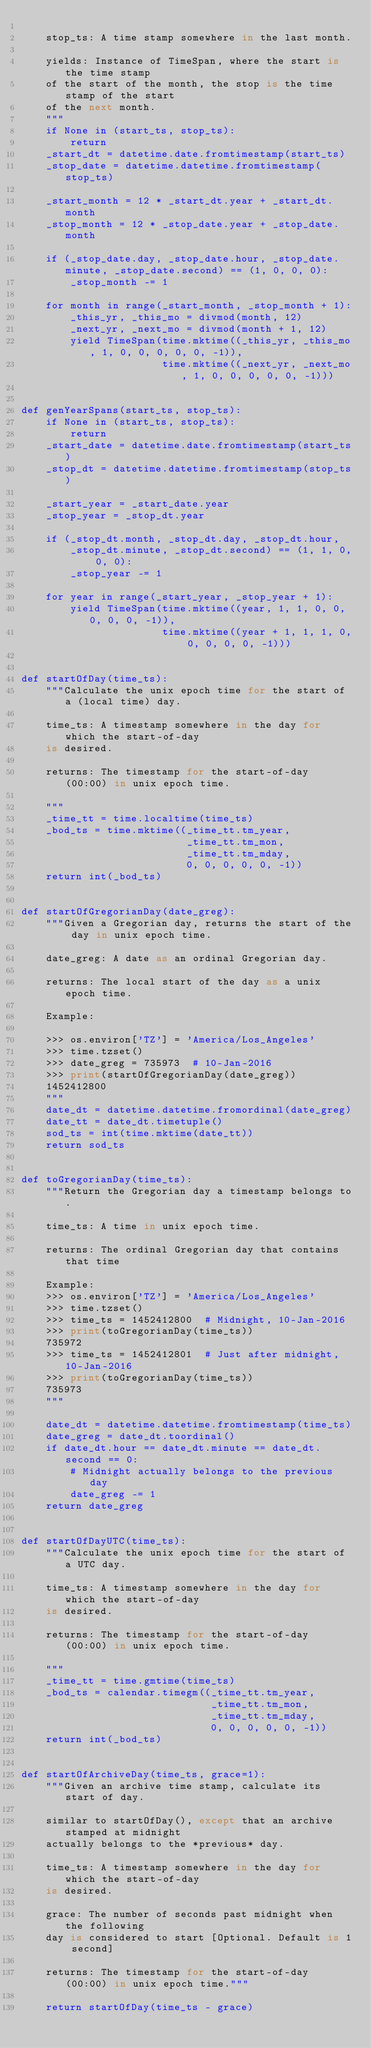Convert code to text. <code><loc_0><loc_0><loc_500><loc_500><_Python_>    
    stop_ts: A time stamp somewhere in the last month.
    
    yields: Instance of TimeSpan, where the start is the time stamp
    of the start of the month, the stop is the time stamp of the start
    of the next month.
    """
    if None in (start_ts, stop_ts):
        return
    _start_dt = datetime.date.fromtimestamp(start_ts)
    _stop_date = datetime.datetime.fromtimestamp(stop_ts)

    _start_month = 12 * _start_dt.year + _start_dt.month
    _stop_month = 12 * _stop_date.year + _stop_date.month

    if (_stop_date.day, _stop_date.hour, _stop_date.minute, _stop_date.second) == (1, 0, 0, 0):
        _stop_month -= 1

    for month in range(_start_month, _stop_month + 1):
        _this_yr, _this_mo = divmod(month, 12)
        _next_yr, _next_mo = divmod(month + 1, 12)
        yield TimeSpan(time.mktime((_this_yr, _this_mo, 1, 0, 0, 0, 0, 0, -1)),
                       time.mktime((_next_yr, _next_mo, 1, 0, 0, 0, 0, 0, -1)))


def genYearSpans(start_ts, stop_ts):
    if None in (start_ts, stop_ts):
        return
    _start_date = datetime.date.fromtimestamp(start_ts)
    _stop_dt = datetime.datetime.fromtimestamp(stop_ts)

    _start_year = _start_date.year
    _stop_year = _stop_dt.year

    if (_stop_dt.month, _stop_dt.day, _stop_dt.hour,
        _stop_dt.minute, _stop_dt.second) == (1, 1, 0, 0, 0):
        _stop_year -= 1

    for year in range(_start_year, _stop_year + 1):
        yield TimeSpan(time.mktime((year, 1, 1, 0, 0, 0, 0, 0, -1)),
                       time.mktime((year + 1, 1, 1, 0, 0, 0, 0, 0, -1)))


def startOfDay(time_ts):
    """Calculate the unix epoch time for the start of a (local time) day.
    
    time_ts: A timestamp somewhere in the day for which the start-of-day
    is desired.
    
    returns: The timestamp for the start-of-day (00:00) in unix epoch time.
    
    """
    _time_tt = time.localtime(time_ts)
    _bod_ts = time.mktime((_time_tt.tm_year,
                           _time_tt.tm_mon,
                           _time_tt.tm_mday,
                           0, 0, 0, 0, 0, -1))
    return int(_bod_ts)


def startOfGregorianDay(date_greg):
    """Given a Gregorian day, returns the start of the day in unix epoch time.
    
    date_greg: A date as an ordinal Gregorian day.
    
    returns: The local start of the day as a unix epoch time.

    Example:
    
    >>> os.environ['TZ'] = 'America/Los_Angeles'
    >>> time.tzset()
    >>> date_greg = 735973  # 10-Jan-2016
    >>> print(startOfGregorianDay(date_greg))
    1452412800
    """
    date_dt = datetime.datetime.fromordinal(date_greg)
    date_tt = date_dt.timetuple()
    sod_ts = int(time.mktime(date_tt))
    return sod_ts


def toGregorianDay(time_ts):
    """Return the Gregorian day a timestamp belongs to.
    
    time_ts: A time in unix epoch time.
    
    returns: The ordinal Gregorian day that contains that time
    
    Example:
    >>> os.environ['TZ'] = 'America/Los_Angeles'
    >>> time.tzset()
    >>> time_ts = 1452412800  # Midnight, 10-Jan-2016
    >>> print(toGregorianDay(time_ts))
    735972
    >>> time_ts = 1452412801  # Just after midnight, 10-Jan-2016
    >>> print(toGregorianDay(time_ts))
    735973
    """

    date_dt = datetime.datetime.fromtimestamp(time_ts)
    date_greg = date_dt.toordinal()
    if date_dt.hour == date_dt.minute == date_dt.second == 0:
        # Midnight actually belongs to the previous day
        date_greg -= 1
    return date_greg


def startOfDayUTC(time_ts):
    """Calculate the unix epoch time for the start of a UTC day.
    
    time_ts: A timestamp somewhere in the day for which the start-of-day
    is desired.
    
    returns: The timestamp for the start-of-day (00:00) in unix epoch time.
    
    """
    _time_tt = time.gmtime(time_ts)
    _bod_ts = calendar.timegm((_time_tt.tm_year,
                               _time_tt.tm_mon,
                               _time_tt.tm_mday,
                               0, 0, 0, 0, 0, -1))
    return int(_bod_ts)


def startOfArchiveDay(time_ts, grace=1):
    """Given an archive time stamp, calculate its start of day.
    
    similar to startOfDay(), except that an archive stamped at midnight
    actually belongs to the *previous* day.

    time_ts: A timestamp somewhere in the day for which the start-of-day
    is desired.
    
    grace: The number of seconds past midnight when the following
    day is considered to start [Optional. Default is 1 second]
    
    returns: The timestamp for the start-of-day (00:00) in unix epoch time."""

    return startOfDay(time_ts - grace)

</code> 